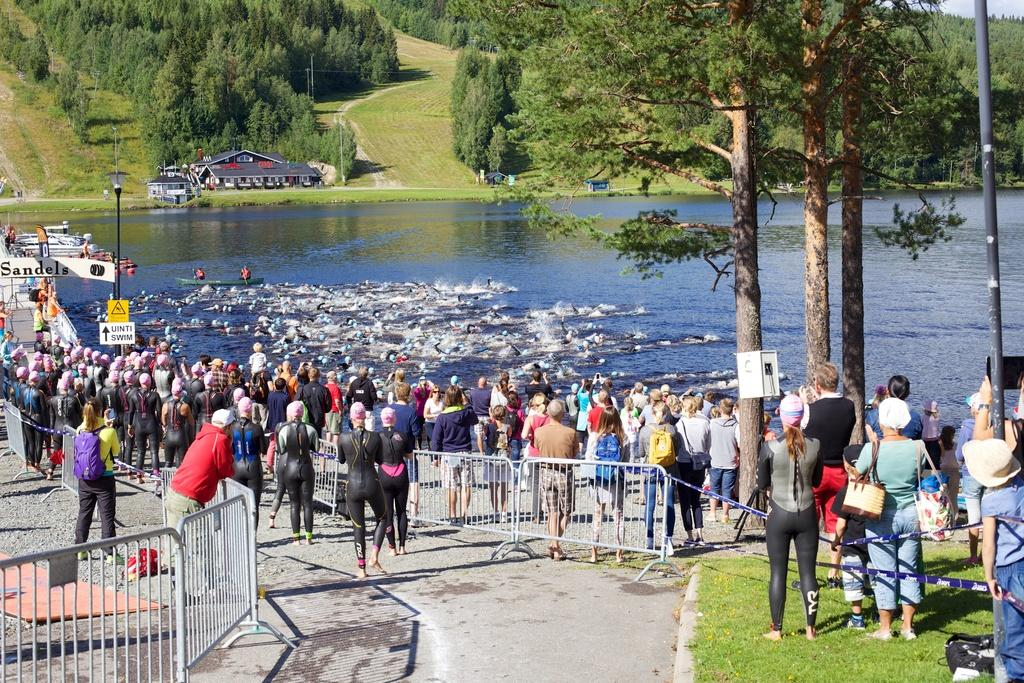How many people are in the image? There are people in the image, but the exact number is not specified. What are the people in the image doing? The people in the image are swimming in the water. What can be seen near the water in the image? There is a railing, grass, poles, and boards visible near the water in the image. What else can be seen in the image? There are boats and houses in the image. What is visible in the background of the image? There are trees in the background of the image. What type of pot is being used by the minister in the image? There is no minister or pot present in the image. What is the minister using to write on the pencil in the image? There is no minister or pencil present in the image. 